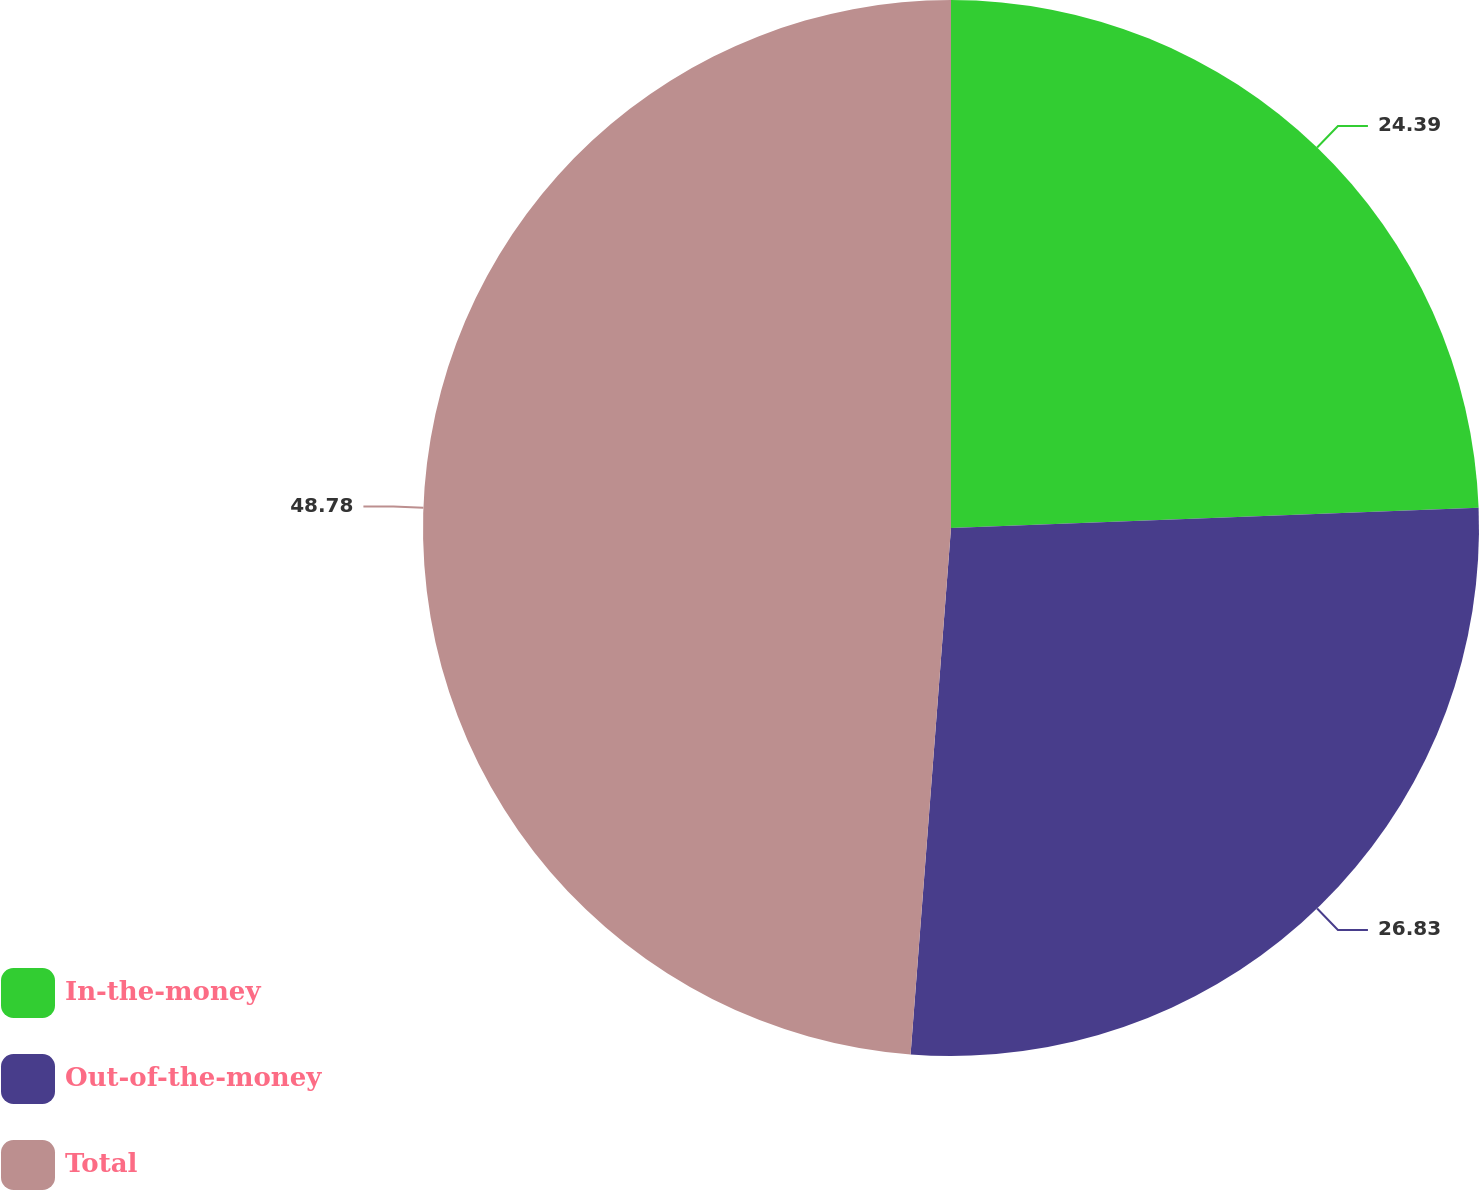<chart> <loc_0><loc_0><loc_500><loc_500><pie_chart><fcel>In-the-money<fcel>Out-of-the-money<fcel>Total<nl><fcel>24.39%<fcel>26.83%<fcel>48.78%<nl></chart> 